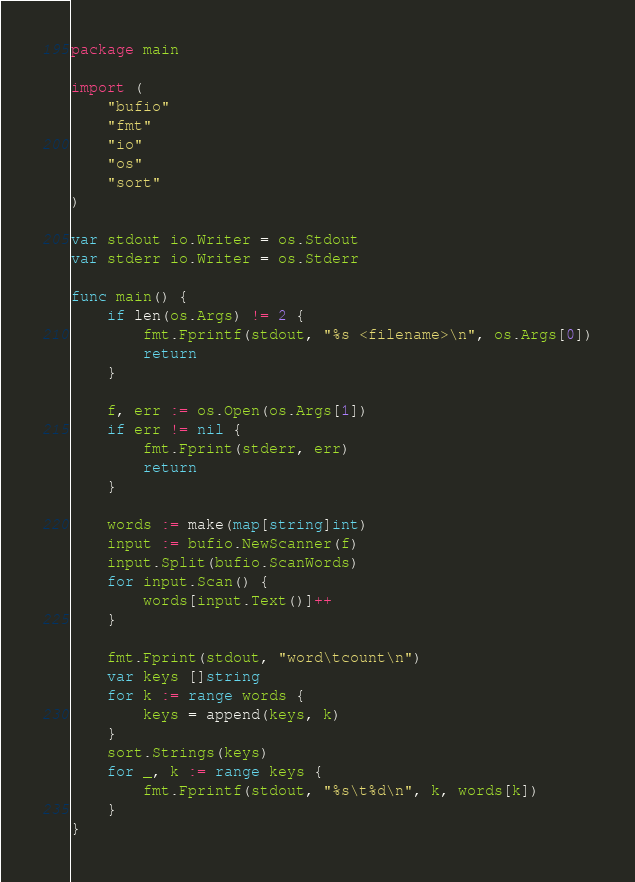<code> <loc_0><loc_0><loc_500><loc_500><_Go_>package main

import (
	"bufio"
	"fmt"
	"io"
	"os"
	"sort"
)

var stdout io.Writer = os.Stdout
var stderr io.Writer = os.Stderr

func main() {
	if len(os.Args) != 2 {
		fmt.Fprintf(stdout, "%s <filename>\n", os.Args[0])
		return
	}

	f, err := os.Open(os.Args[1])
	if err != nil {
		fmt.Fprint(stderr, err)
		return
	}

	words := make(map[string]int)
	input := bufio.NewScanner(f)
	input.Split(bufio.ScanWords)
	for input.Scan() {
		words[input.Text()]++
	}

	fmt.Fprint(stdout, "word\tcount\n")
	var keys []string
	for k := range words {
		keys = append(keys, k)
	}
	sort.Strings(keys)
	for _, k := range keys {
		fmt.Fprintf(stdout, "%s\t%d\n", k, words[k])
	}
}
</code> 